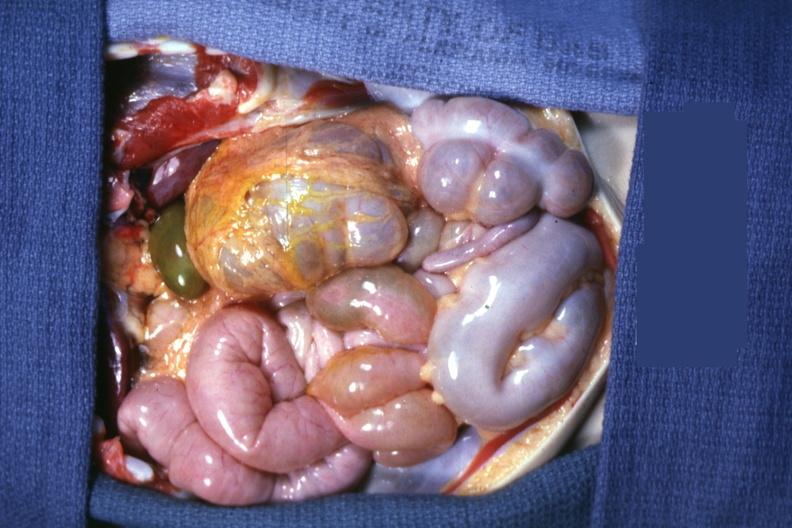what is present?
Answer the question using a single word or phrase. Situs inversus 